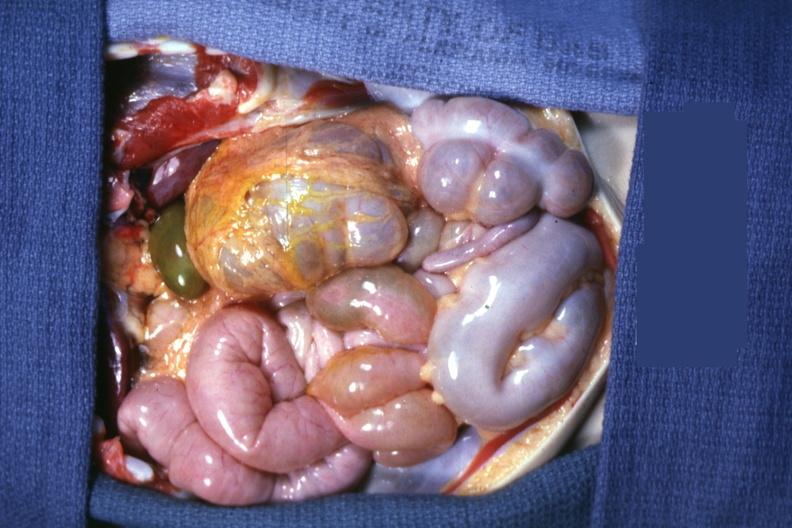what is present?
Answer the question using a single word or phrase. Situs inversus 